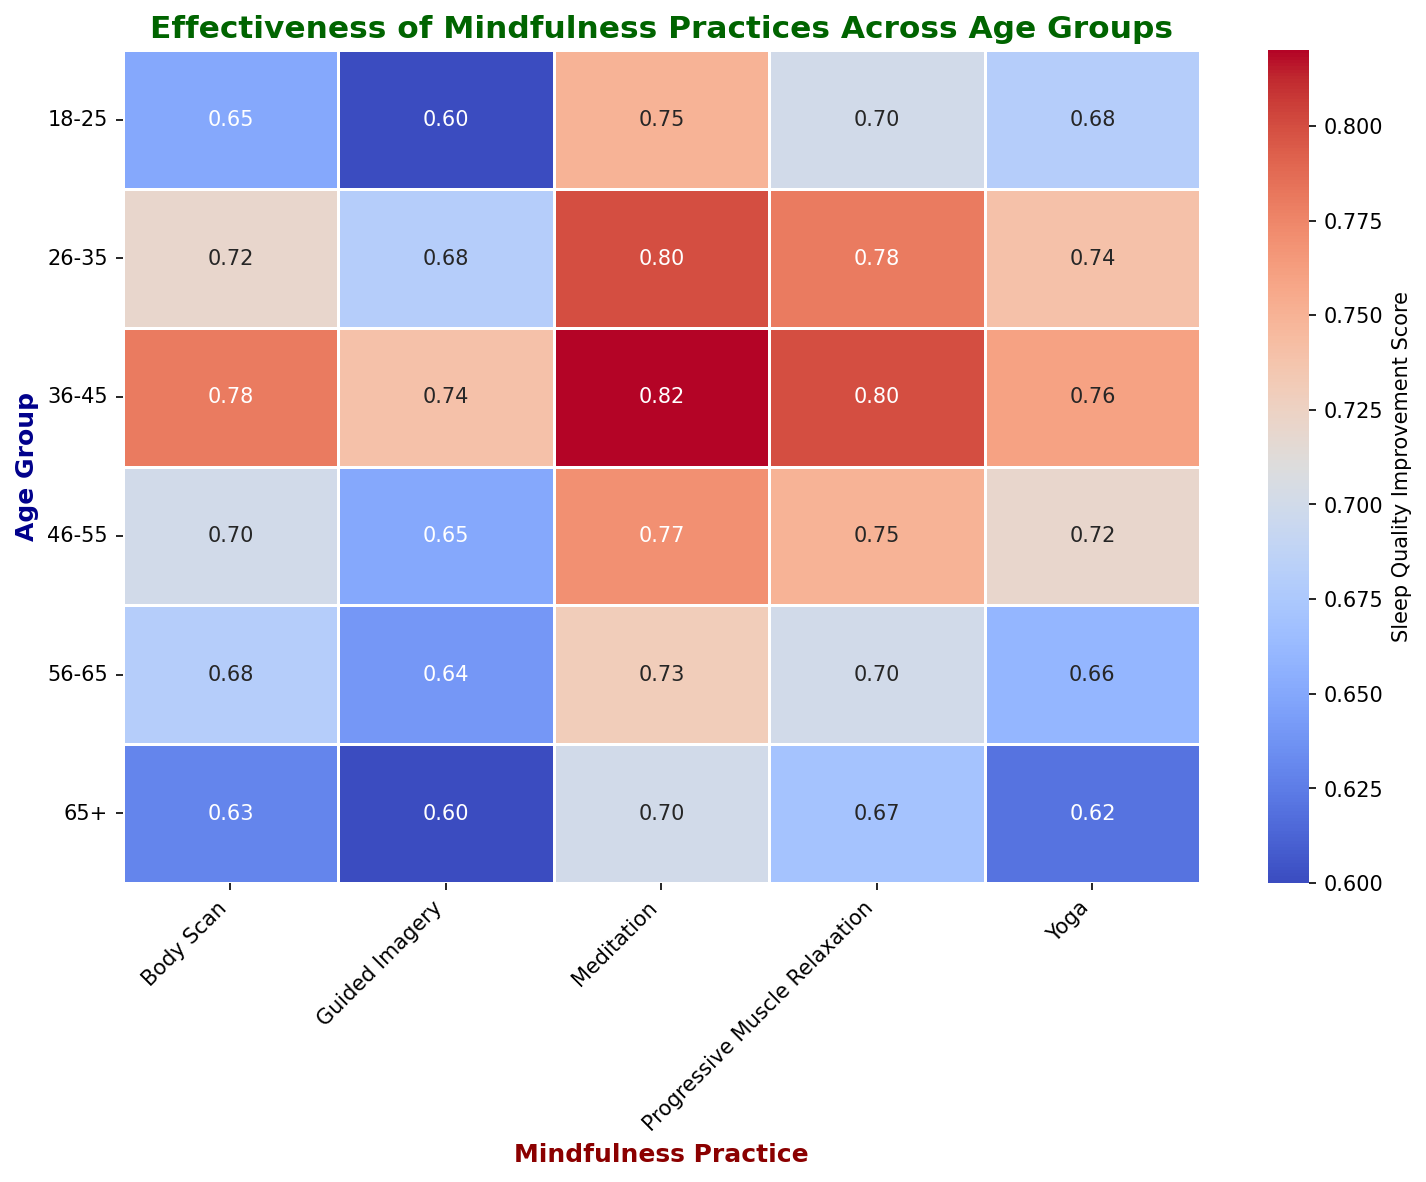what age group sees the greatest improvement in sleep quality from mindfulness practices? By examining the heatmap, the age group 36-45 consistently shows high sleep quality improvement scores across different mindfulness practices, with the highest being for Meditation at 0.82.
Answer: 36-45 which mindfulness practice has the highest average sleep quality improvement score across all age groups? To find the highest average, calculate the average sleep quality improvement score for each mindfulness practice across all age groups. Meditation has the highest scores in multiple age groups, making it the likely candidate.
Answer: Meditation how does the effectiveness of Yoga compare between the youngest (18-25) and oldest (65+) age groups? Look at the heatmap scores for Yoga in the 18-25 and 65+ age groups. The 18-25 age group has a score of 0.68, while the 65+ age group has a lower score of 0.62.
Answer: Higher in 18-25 which age group has the least improvement in sleep quality using Guided Imagery? Find the lowest number in the column for Guided Imagery. The 65+ age group shows the least improvement with a score of 0.60.
Answer: 65+ what is the difference in sleep quality improvement scores between Body Scan and Progressive Muscle Relaxation for the 26-35 age group? Subtract the Body Scan score from the Progressive Muscle Relaxation score for the 26-35 age group. 0.78 (PMR) - 0.72 (Body Scan) = 0.06.
Answer: 0.06 which age group shows a more pronounced benefit from Progressive Muscle Relaxation compared to Guided Imagery? Compare each age group's scores for Progressive Muscle Relaxation and Guided Imagery, then find the largest difference. The 36-45 age group shows the greatest difference with 0.80 (PMR) vs. 0.74 (Guided Imagery).
Answer: 36-45 does the effectiveness of Meditation increase or decrease with age? Observe the trend of Meditation scores across the age groups. The scores decrease slightly with age, from 0.75 in the 18-25 group to 0.70 in the 65+ group.
Answer: Decrease for the age group 46-55, which mindfulness practice provides the second highest improvement in sleep quality? Look at the scores for the 46-55 age group and identify the second highest score after Meditation. Progressive Muscle Relaxation with a score of 0.75 is the second highest.
Answer: Progressive Muscle Relaxation how does the average effectiveness of all mindfulness practices combined vary between the 18-25 and 56-65 age groups? Calculate the average score for each age group by summing their scores and dividing by the number of practices. For 18-25, the average is (0.75 + 0.65 + 0.60 + 0.70 + 0.68) / 5 = 0.68; for 56-65, the average is (0.73 + 0.68 + 0.64 + 0.70 + 0.66) / 5 = 0.682.
Answer: Slightly higher in 56-65 